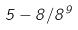Convert formula to latex. <formula><loc_0><loc_0><loc_500><loc_500>5 - 8 / 8 ^ { 9 }</formula> 